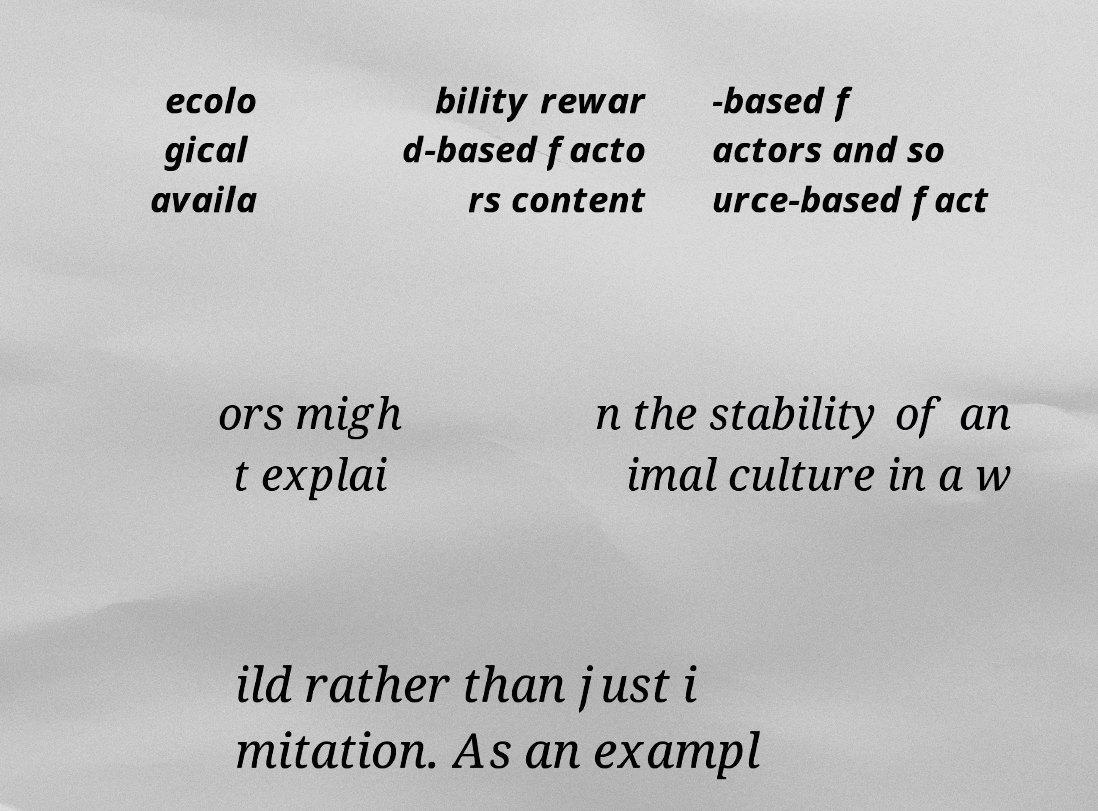I need the written content from this picture converted into text. Can you do that? ecolo gical availa bility rewar d-based facto rs content -based f actors and so urce-based fact ors migh t explai n the stability of an imal culture in a w ild rather than just i mitation. As an exampl 